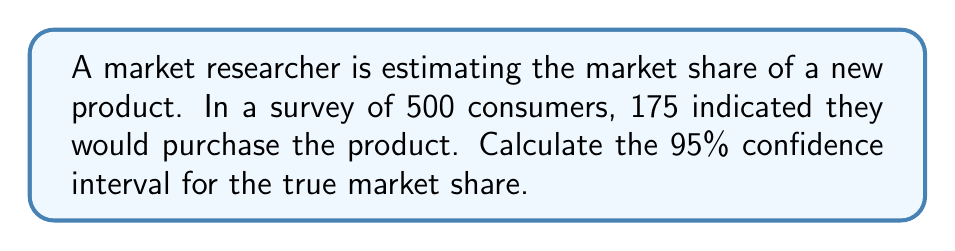Provide a solution to this math problem. To calculate the confidence interval for market share, we'll use the following steps:

1. Calculate the sample proportion:
   $$\hat{p} = \frac{175}{500} = 0.35$$

2. Calculate the standard error:
   $$SE = \sqrt{\frac{\hat{p}(1-\hat{p})}{n}} = \sqrt{\frac{0.35(1-0.35)}{500}} = 0.0213$$

3. For a 95% confidence interval, use z-score of 1.96 (from standard normal distribution table).

4. Calculate the margin of error:
   $$ME = 1.96 \times SE = 1.96 \times 0.0213 = 0.0418$$

5. Calculate the confidence interval:
   $$CI = \hat{p} \pm ME$$
   $$CI = 0.35 \pm 0.0418$$
   $$CI = [0.3082, 0.3918]$$

6. Convert to percentages:
   $$CI = [30.82\%, 39.18\%]$$
Answer: [30.82%, 39.18%] 